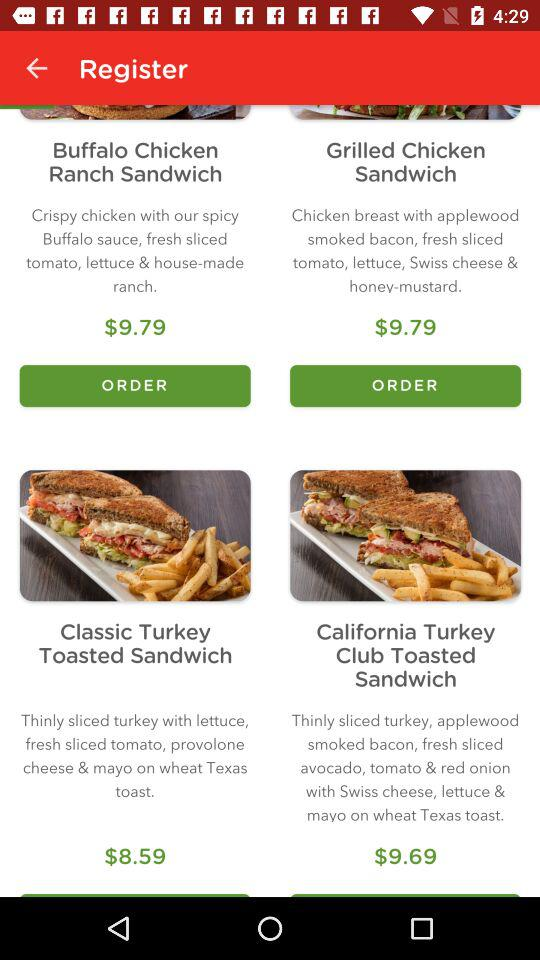How much more is the California Turkey Club Toasted Sandwich than the Grilled Chicken Sandwich?
Answer the question using a single word or phrase. $0.90 